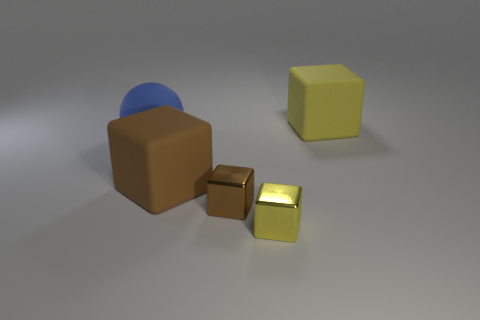Are there any other cubes of the same size as the brown metal block?
Your response must be concise. Yes. How big is the matte sphere?
Provide a succinct answer. Large. What size is the yellow thing that is right of the small shiny object in front of the tiny brown cube?
Your answer should be very brief. Large. How many yellow cylinders are there?
Give a very brief answer. 0. What number of other blue things have the same material as the large blue object?
Your response must be concise. 0. There is another matte thing that is the same shape as the large brown rubber object; what size is it?
Provide a short and direct response. Large. What is the small yellow object made of?
Offer a very short reply. Metal. What material is the yellow thing that is to the left of the matte object that is to the right of the tiny cube that is on the right side of the small brown metallic block?
Ensure brevity in your answer.  Metal. Is there anything else that has the same shape as the blue matte thing?
Your answer should be very brief. No. There is another big rubber thing that is the same shape as the large brown thing; what is its color?
Provide a short and direct response. Yellow. 